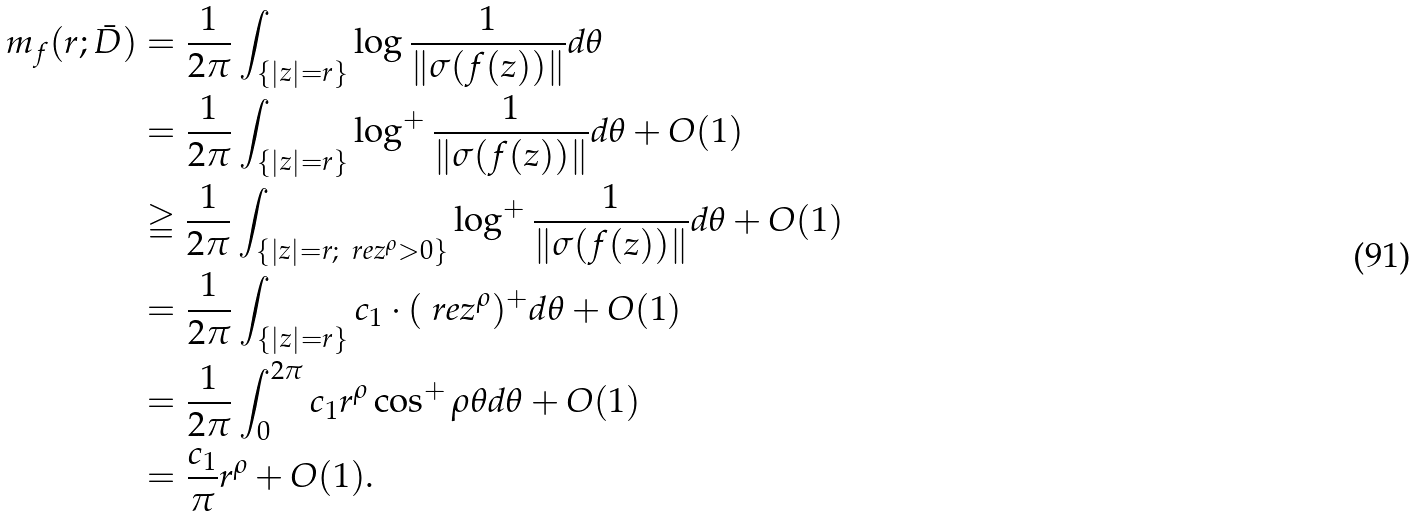<formula> <loc_0><loc_0><loc_500><loc_500>m _ { f } ( r ; \bar { D } ) & = \frac { 1 } { 2 \pi } \int _ { \{ | z | = r \} } \log \frac { 1 } { \| \sigma ( f ( z ) ) \| } d \theta \\ & = \frac { 1 } { 2 \pi } \int _ { \{ | z | = r \} } \log ^ { + } \frac { 1 } { \| \sigma ( f ( z ) ) \| } d \theta + O ( 1 ) \\ & \geqq \frac { 1 } { 2 \pi } \int _ { \{ | z | = r ; \, \ r e z ^ { \rho } > 0 \} } \log ^ { + } \frac { 1 } { \| \sigma ( f ( z ) ) \| } d \theta + O ( 1 ) \\ & = \frac { 1 } { 2 \pi } \int _ { { \{ | z | = r \} } } c _ { 1 } \cdot ( \ r e z ^ { \rho } ) ^ { + } d \theta + O ( 1 ) \\ & = \frac { 1 } { 2 \pi } \int _ { 0 } ^ { 2 \pi } c _ { 1 } r ^ { \rho } \cos ^ { + } \rho \theta d \theta + O ( 1 ) \\ & = \frac { c _ { 1 } } { \pi } r ^ { \rho } + O ( 1 ) .</formula> 